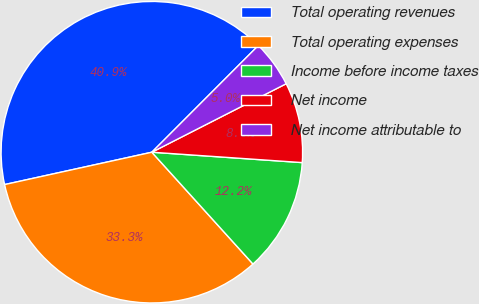<chart> <loc_0><loc_0><loc_500><loc_500><pie_chart><fcel>Total operating revenues<fcel>Total operating expenses<fcel>Income before income taxes<fcel>Net income<fcel>Net income attributable to<nl><fcel>40.93%<fcel>33.26%<fcel>12.2%<fcel>8.6%<fcel>5.01%<nl></chart> 